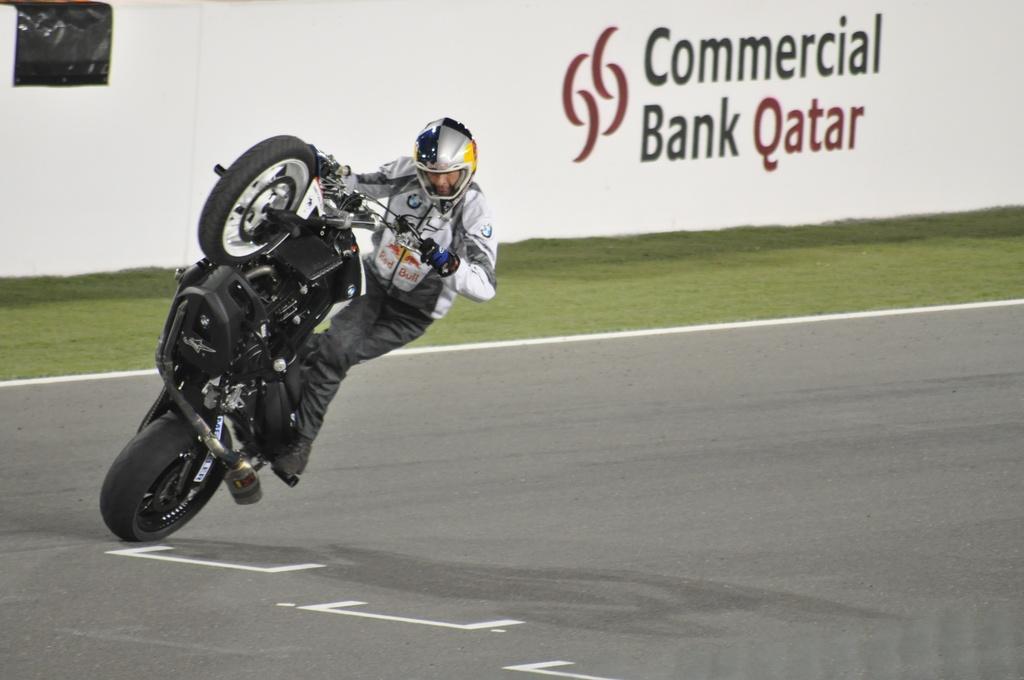In one or two sentences, can you explain what this image depicts? On the left side of the image there is a man wearing a helmet and riding the motorcycle on the road. Beside the road, I can see the grass. In the background there is a wall on which I can see some text. 